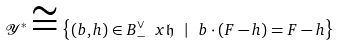Convert formula to latex. <formula><loc_0><loc_0><loc_500><loc_500>\mathcal { Y } ^ { * } \cong \left \{ ( b , h ) \in B ^ { \vee } _ { - } \ x \mathfrak h \ | \ b \cdot ( F - h ) = F - h \right \}</formula> 